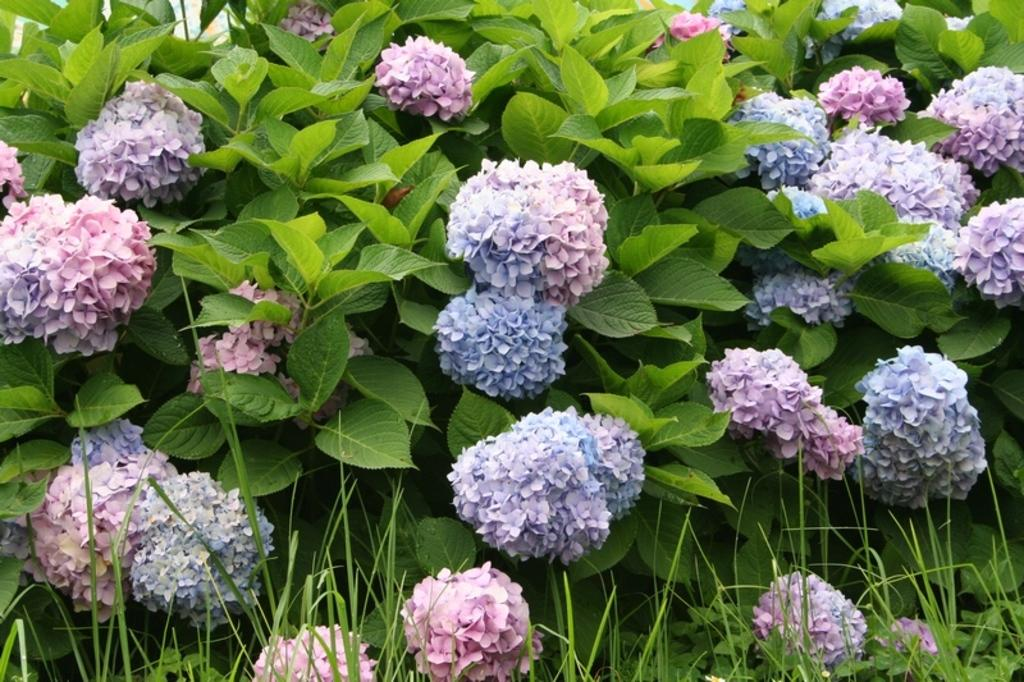What colors are the flowers in the image? The flowers in the image are blue and pink. What type of plants do the flowers grow on? The flowers grow on plants. What type of vegetation is visible in the image? Grass is visible in the image. What type of competition is being held in the image? There is no competition present in the image; it features blue and pink flowers on plants with grass visible in the background. 